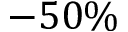<formula> <loc_0><loc_0><loc_500><loc_500>- 5 0 \%</formula> 